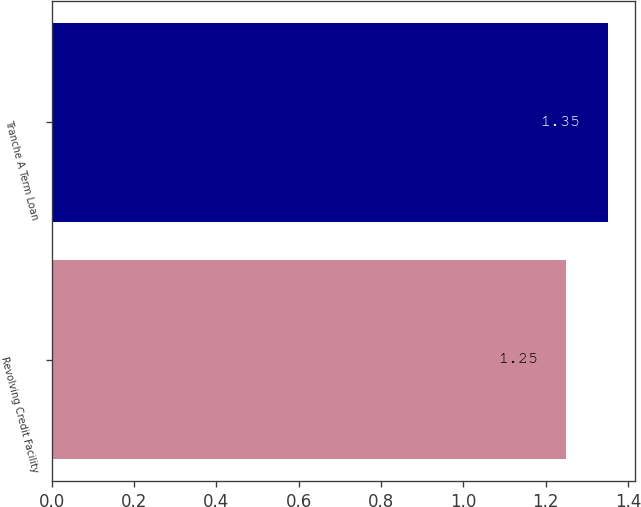Convert chart to OTSL. <chart><loc_0><loc_0><loc_500><loc_500><bar_chart><fcel>Revolving Credit Facility<fcel>Tranche A Term Loan<nl><fcel>1.25<fcel>1.35<nl></chart> 